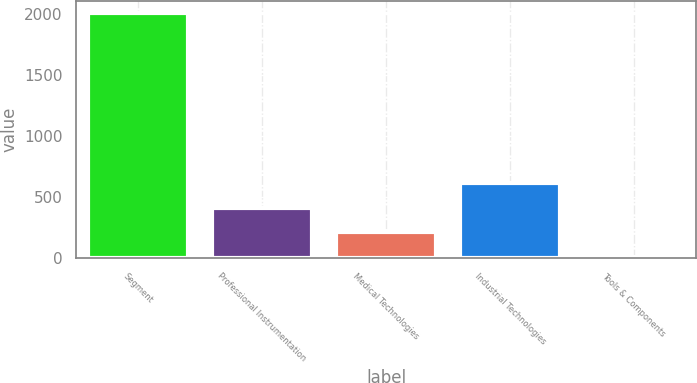Convert chart to OTSL. <chart><loc_0><loc_0><loc_500><loc_500><bar_chart><fcel>Segment<fcel>Professional Instrumentation<fcel>Medical Technologies<fcel>Industrial Technologies<fcel>Tools & Components<nl><fcel>2006<fcel>412.4<fcel>213.2<fcel>611.6<fcel>14<nl></chart> 